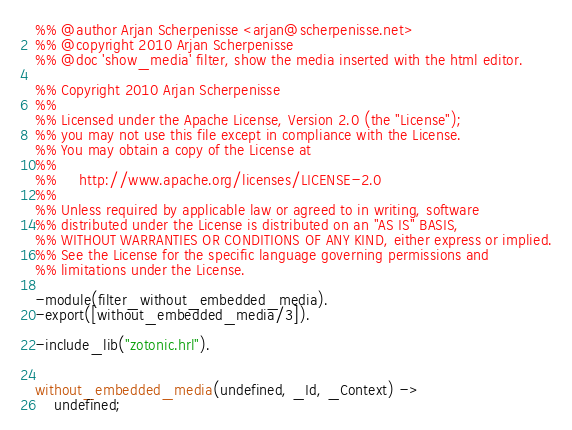Convert code to text. <code><loc_0><loc_0><loc_500><loc_500><_Erlang_>%% @author Arjan Scherpenisse <arjan@scherpenisse.net>
%% @copyright 2010 Arjan Scherpenisse
%% @doc 'show_media' filter, show the media inserted with the html editor.

%% Copyright 2010 Arjan Scherpenisse
%%
%% Licensed under the Apache License, Version 2.0 (the "License");
%% you may not use this file except in compliance with the License.
%% You may obtain a copy of the License at
%%
%%     http://www.apache.org/licenses/LICENSE-2.0
%%
%% Unless required by applicable law or agreed to in writing, software
%% distributed under the License is distributed on an "AS IS" BASIS,
%% WITHOUT WARRANTIES OR CONDITIONS OF ANY KIND, either express or implied.
%% See the License for the specific language governing permissions and
%% limitations under the License.

-module(filter_without_embedded_media).
-export([without_embedded_media/3]).

-include_lib("zotonic.hrl").


without_embedded_media(undefined, _Id, _Context) ->
    undefined;</code> 